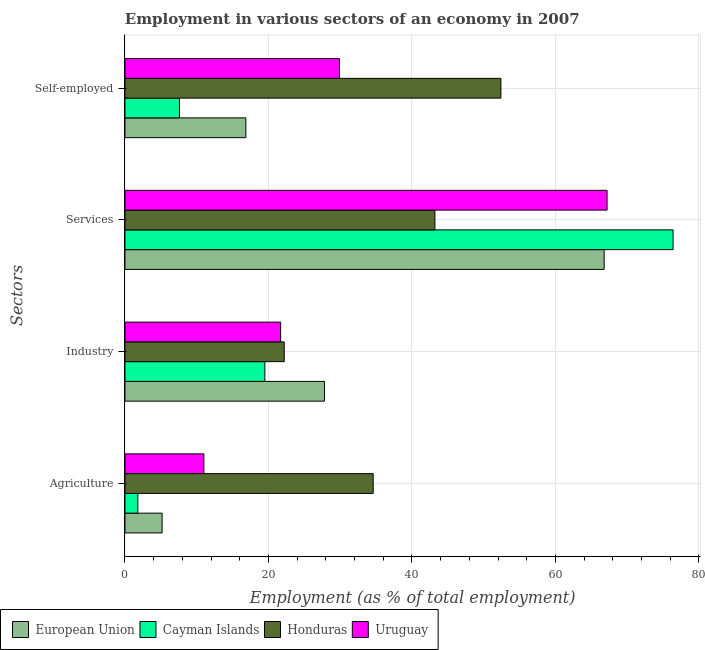How many different coloured bars are there?
Provide a succinct answer. 4. How many groups of bars are there?
Your response must be concise. 4. How many bars are there on the 4th tick from the top?
Make the answer very short. 4. How many bars are there on the 1st tick from the bottom?
Give a very brief answer. 4. What is the label of the 4th group of bars from the top?
Keep it short and to the point. Agriculture. What is the percentage of workers in services in European Union?
Provide a short and direct response. 66.79. Across all countries, what is the maximum percentage of workers in services?
Make the answer very short. 76.4. Across all countries, what is the minimum percentage of workers in services?
Your response must be concise. 43.2. In which country was the percentage of workers in agriculture maximum?
Your answer should be very brief. Honduras. In which country was the percentage of workers in services minimum?
Provide a succinct answer. Honduras. What is the total percentage of workers in agriculture in the graph?
Offer a very short reply. 52.58. What is the difference between the percentage of workers in agriculture in Cayman Islands and that in European Union?
Make the answer very short. -3.38. What is the difference between the percentage of workers in industry in European Union and the percentage of self employed workers in Cayman Islands?
Make the answer very short. 20.21. What is the average percentage of workers in services per country?
Your answer should be compact. 63.4. What is the difference between the percentage of workers in agriculture and percentage of self employed workers in Cayman Islands?
Provide a succinct answer. -5.8. What is the ratio of the percentage of workers in industry in European Union to that in Uruguay?
Provide a short and direct response. 1.28. Is the difference between the percentage of workers in services in European Union and Honduras greater than the difference between the percentage of workers in agriculture in European Union and Honduras?
Your answer should be very brief. Yes. What is the difference between the highest and the second highest percentage of workers in industry?
Your response must be concise. 5.61. What is the difference between the highest and the lowest percentage of workers in services?
Make the answer very short. 33.2. What does the 3rd bar from the top in Self-employed represents?
Offer a very short reply. Cayman Islands. What does the 4th bar from the bottom in Agriculture represents?
Offer a terse response. Uruguay. How many bars are there?
Make the answer very short. 16. How many countries are there in the graph?
Your answer should be compact. 4. Does the graph contain any zero values?
Provide a succinct answer. No. Where does the legend appear in the graph?
Offer a very short reply. Bottom left. How are the legend labels stacked?
Your response must be concise. Horizontal. What is the title of the graph?
Provide a short and direct response. Employment in various sectors of an economy in 2007. Does "Micronesia" appear as one of the legend labels in the graph?
Your answer should be compact. No. What is the label or title of the X-axis?
Your response must be concise. Employment (as % of total employment). What is the label or title of the Y-axis?
Your answer should be compact. Sectors. What is the Employment (as % of total employment) of European Union in Agriculture?
Offer a very short reply. 5.18. What is the Employment (as % of total employment) in Cayman Islands in Agriculture?
Offer a terse response. 1.8. What is the Employment (as % of total employment) in Honduras in Agriculture?
Offer a terse response. 34.6. What is the Employment (as % of total employment) of European Union in Industry?
Your response must be concise. 27.81. What is the Employment (as % of total employment) in Cayman Islands in Industry?
Your answer should be compact. 19.5. What is the Employment (as % of total employment) of Honduras in Industry?
Keep it short and to the point. 22.2. What is the Employment (as % of total employment) of Uruguay in Industry?
Your answer should be very brief. 21.7. What is the Employment (as % of total employment) in European Union in Services?
Keep it short and to the point. 66.79. What is the Employment (as % of total employment) of Cayman Islands in Services?
Your answer should be compact. 76.4. What is the Employment (as % of total employment) in Honduras in Services?
Your answer should be very brief. 43.2. What is the Employment (as % of total employment) of Uruguay in Services?
Your answer should be very brief. 67.2. What is the Employment (as % of total employment) in European Union in Self-employed?
Provide a succinct answer. 16.85. What is the Employment (as % of total employment) in Cayman Islands in Self-employed?
Your response must be concise. 7.6. What is the Employment (as % of total employment) in Honduras in Self-employed?
Offer a terse response. 52.4. What is the Employment (as % of total employment) in Uruguay in Self-employed?
Your response must be concise. 29.9. Across all Sectors, what is the maximum Employment (as % of total employment) in European Union?
Your answer should be compact. 66.79. Across all Sectors, what is the maximum Employment (as % of total employment) in Cayman Islands?
Your answer should be compact. 76.4. Across all Sectors, what is the maximum Employment (as % of total employment) in Honduras?
Your answer should be very brief. 52.4. Across all Sectors, what is the maximum Employment (as % of total employment) in Uruguay?
Your response must be concise. 67.2. Across all Sectors, what is the minimum Employment (as % of total employment) of European Union?
Ensure brevity in your answer.  5.18. Across all Sectors, what is the minimum Employment (as % of total employment) of Cayman Islands?
Ensure brevity in your answer.  1.8. Across all Sectors, what is the minimum Employment (as % of total employment) of Honduras?
Make the answer very short. 22.2. Across all Sectors, what is the minimum Employment (as % of total employment) of Uruguay?
Offer a terse response. 11. What is the total Employment (as % of total employment) of European Union in the graph?
Offer a very short reply. 116.63. What is the total Employment (as % of total employment) of Cayman Islands in the graph?
Provide a succinct answer. 105.3. What is the total Employment (as % of total employment) in Honduras in the graph?
Provide a short and direct response. 152.4. What is the total Employment (as % of total employment) in Uruguay in the graph?
Provide a short and direct response. 129.8. What is the difference between the Employment (as % of total employment) in European Union in Agriculture and that in Industry?
Give a very brief answer. -22.63. What is the difference between the Employment (as % of total employment) in Cayman Islands in Agriculture and that in Industry?
Your answer should be compact. -17.7. What is the difference between the Employment (as % of total employment) of Honduras in Agriculture and that in Industry?
Provide a succinct answer. 12.4. What is the difference between the Employment (as % of total employment) in Uruguay in Agriculture and that in Industry?
Your answer should be compact. -10.7. What is the difference between the Employment (as % of total employment) of European Union in Agriculture and that in Services?
Give a very brief answer. -61.61. What is the difference between the Employment (as % of total employment) of Cayman Islands in Agriculture and that in Services?
Keep it short and to the point. -74.6. What is the difference between the Employment (as % of total employment) of Honduras in Agriculture and that in Services?
Offer a terse response. -8.6. What is the difference between the Employment (as % of total employment) in Uruguay in Agriculture and that in Services?
Provide a succinct answer. -56.2. What is the difference between the Employment (as % of total employment) of European Union in Agriculture and that in Self-employed?
Offer a very short reply. -11.67. What is the difference between the Employment (as % of total employment) of Honduras in Agriculture and that in Self-employed?
Ensure brevity in your answer.  -17.8. What is the difference between the Employment (as % of total employment) of Uruguay in Agriculture and that in Self-employed?
Your answer should be compact. -18.9. What is the difference between the Employment (as % of total employment) of European Union in Industry and that in Services?
Your answer should be compact. -38.98. What is the difference between the Employment (as % of total employment) in Cayman Islands in Industry and that in Services?
Your answer should be compact. -56.9. What is the difference between the Employment (as % of total employment) of Uruguay in Industry and that in Services?
Offer a terse response. -45.5. What is the difference between the Employment (as % of total employment) in European Union in Industry and that in Self-employed?
Provide a short and direct response. 10.96. What is the difference between the Employment (as % of total employment) in Cayman Islands in Industry and that in Self-employed?
Your response must be concise. 11.9. What is the difference between the Employment (as % of total employment) in Honduras in Industry and that in Self-employed?
Provide a succinct answer. -30.2. What is the difference between the Employment (as % of total employment) of European Union in Services and that in Self-employed?
Keep it short and to the point. 49.94. What is the difference between the Employment (as % of total employment) of Cayman Islands in Services and that in Self-employed?
Your answer should be very brief. 68.8. What is the difference between the Employment (as % of total employment) in Honduras in Services and that in Self-employed?
Keep it short and to the point. -9.2. What is the difference between the Employment (as % of total employment) in Uruguay in Services and that in Self-employed?
Make the answer very short. 37.3. What is the difference between the Employment (as % of total employment) in European Union in Agriculture and the Employment (as % of total employment) in Cayman Islands in Industry?
Your answer should be compact. -14.32. What is the difference between the Employment (as % of total employment) of European Union in Agriculture and the Employment (as % of total employment) of Honduras in Industry?
Make the answer very short. -17.02. What is the difference between the Employment (as % of total employment) of European Union in Agriculture and the Employment (as % of total employment) of Uruguay in Industry?
Provide a succinct answer. -16.52. What is the difference between the Employment (as % of total employment) of Cayman Islands in Agriculture and the Employment (as % of total employment) of Honduras in Industry?
Offer a terse response. -20.4. What is the difference between the Employment (as % of total employment) in Cayman Islands in Agriculture and the Employment (as % of total employment) in Uruguay in Industry?
Your answer should be very brief. -19.9. What is the difference between the Employment (as % of total employment) of Honduras in Agriculture and the Employment (as % of total employment) of Uruguay in Industry?
Provide a short and direct response. 12.9. What is the difference between the Employment (as % of total employment) in European Union in Agriculture and the Employment (as % of total employment) in Cayman Islands in Services?
Your response must be concise. -71.22. What is the difference between the Employment (as % of total employment) of European Union in Agriculture and the Employment (as % of total employment) of Honduras in Services?
Your answer should be compact. -38.02. What is the difference between the Employment (as % of total employment) of European Union in Agriculture and the Employment (as % of total employment) of Uruguay in Services?
Your answer should be very brief. -62.02. What is the difference between the Employment (as % of total employment) of Cayman Islands in Agriculture and the Employment (as % of total employment) of Honduras in Services?
Your response must be concise. -41.4. What is the difference between the Employment (as % of total employment) of Cayman Islands in Agriculture and the Employment (as % of total employment) of Uruguay in Services?
Give a very brief answer. -65.4. What is the difference between the Employment (as % of total employment) in Honduras in Agriculture and the Employment (as % of total employment) in Uruguay in Services?
Ensure brevity in your answer.  -32.6. What is the difference between the Employment (as % of total employment) in European Union in Agriculture and the Employment (as % of total employment) in Cayman Islands in Self-employed?
Give a very brief answer. -2.42. What is the difference between the Employment (as % of total employment) of European Union in Agriculture and the Employment (as % of total employment) of Honduras in Self-employed?
Your response must be concise. -47.22. What is the difference between the Employment (as % of total employment) in European Union in Agriculture and the Employment (as % of total employment) in Uruguay in Self-employed?
Provide a short and direct response. -24.72. What is the difference between the Employment (as % of total employment) in Cayman Islands in Agriculture and the Employment (as % of total employment) in Honduras in Self-employed?
Make the answer very short. -50.6. What is the difference between the Employment (as % of total employment) of Cayman Islands in Agriculture and the Employment (as % of total employment) of Uruguay in Self-employed?
Your answer should be compact. -28.1. What is the difference between the Employment (as % of total employment) of Honduras in Agriculture and the Employment (as % of total employment) of Uruguay in Self-employed?
Provide a succinct answer. 4.7. What is the difference between the Employment (as % of total employment) in European Union in Industry and the Employment (as % of total employment) in Cayman Islands in Services?
Make the answer very short. -48.59. What is the difference between the Employment (as % of total employment) of European Union in Industry and the Employment (as % of total employment) of Honduras in Services?
Your response must be concise. -15.39. What is the difference between the Employment (as % of total employment) in European Union in Industry and the Employment (as % of total employment) in Uruguay in Services?
Your response must be concise. -39.39. What is the difference between the Employment (as % of total employment) in Cayman Islands in Industry and the Employment (as % of total employment) in Honduras in Services?
Your response must be concise. -23.7. What is the difference between the Employment (as % of total employment) in Cayman Islands in Industry and the Employment (as % of total employment) in Uruguay in Services?
Your answer should be compact. -47.7. What is the difference between the Employment (as % of total employment) of Honduras in Industry and the Employment (as % of total employment) of Uruguay in Services?
Make the answer very short. -45. What is the difference between the Employment (as % of total employment) of European Union in Industry and the Employment (as % of total employment) of Cayman Islands in Self-employed?
Provide a short and direct response. 20.21. What is the difference between the Employment (as % of total employment) in European Union in Industry and the Employment (as % of total employment) in Honduras in Self-employed?
Provide a succinct answer. -24.59. What is the difference between the Employment (as % of total employment) in European Union in Industry and the Employment (as % of total employment) in Uruguay in Self-employed?
Make the answer very short. -2.09. What is the difference between the Employment (as % of total employment) in Cayman Islands in Industry and the Employment (as % of total employment) in Honduras in Self-employed?
Keep it short and to the point. -32.9. What is the difference between the Employment (as % of total employment) in Honduras in Industry and the Employment (as % of total employment) in Uruguay in Self-employed?
Make the answer very short. -7.7. What is the difference between the Employment (as % of total employment) of European Union in Services and the Employment (as % of total employment) of Cayman Islands in Self-employed?
Provide a succinct answer. 59.19. What is the difference between the Employment (as % of total employment) of European Union in Services and the Employment (as % of total employment) of Honduras in Self-employed?
Your answer should be very brief. 14.39. What is the difference between the Employment (as % of total employment) in European Union in Services and the Employment (as % of total employment) in Uruguay in Self-employed?
Make the answer very short. 36.89. What is the difference between the Employment (as % of total employment) of Cayman Islands in Services and the Employment (as % of total employment) of Uruguay in Self-employed?
Provide a short and direct response. 46.5. What is the average Employment (as % of total employment) in European Union per Sectors?
Keep it short and to the point. 29.16. What is the average Employment (as % of total employment) in Cayman Islands per Sectors?
Give a very brief answer. 26.32. What is the average Employment (as % of total employment) of Honduras per Sectors?
Your answer should be very brief. 38.1. What is the average Employment (as % of total employment) in Uruguay per Sectors?
Keep it short and to the point. 32.45. What is the difference between the Employment (as % of total employment) in European Union and Employment (as % of total employment) in Cayman Islands in Agriculture?
Your answer should be very brief. 3.38. What is the difference between the Employment (as % of total employment) of European Union and Employment (as % of total employment) of Honduras in Agriculture?
Provide a succinct answer. -29.42. What is the difference between the Employment (as % of total employment) in European Union and Employment (as % of total employment) in Uruguay in Agriculture?
Your answer should be very brief. -5.82. What is the difference between the Employment (as % of total employment) of Cayman Islands and Employment (as % of total employment) of Honduras in Agriculture?
Your response must be concise. -32.8. What is the difference between the Employment (as % of total employment) of Cayman Islands and Employment (as % of total employment) of Uruguay in Agriculture?
Keep it short and to the point. -9.2. What is the difference between the Employment (as % of total employment) of Honduras and Employment (as % of total employment) of Uruguay in Agriculture?
Your answer should be compact. 23.6. What is the difference between the Employment (as % of total employment) of European Union and Employment (as % of total employment) of Cayman Islands in Industry?
Provide a succinct answer. 8.31. What is the difference between the Employment (as % of total employment) of European Union and Employment (as % of total employment) of Honduras in Industry?
Provide a succinct answer. 5.61. What is the difference between the Employment (as % of total employment) of European Union and Employment (as % of total employment) of Uruguay in Industry?
Give a very brief answer. 6.11. What is the difference between the Employment (as % of total employment) of Cayman Islands and Employment (as % of total employment) of Honduras in Industry?
Offer a terse response. -2.7. What is the difference between the Employment (as % of total employment) of Cayman Islands and Employment (as % of total employment) of Uruguay in Industry?
Offer a very short reply. -2.2. What is the difference between the Employment (as % of total employment) in European Union and Employment (as % of total employment) in Cayman Islands in Services?
Make the answer very short. -9.61. What is the difference between the Employment (as % of total employment) of European Union and Employment (as % of total employment) of Honduras in Services?
Your response must be concise. 23.59. What is the difference between the Employment (as % of total employment) in European Union and Employment (as % of total employment) in Uruguay in Services?
Make the answer very short. -0.41. What is the difference between the Employment (as % of total employment) of Cayman Islands and Employment (as % of total employment) of Honduras in Services?
Ensure brevity in your answer.  33.2. What is the difference between the Employment (as % of total employment) of European Union and Employment (as % of total employment) of Cayman Islands in Self-employed?
Provide a short and direct response. 9.25. What is the difference between the Employment (as % of total employment) in European Union and Employment (as % of total employment) in Honduras in Self-employed?
Provide a succinct answer. -35.55. What is the difference between the Employment (as % of total employment) of European Union and Employment (as % of total employment) of Uruguay in Self-employed?
Your answer should be very brief. -13.05. What is the difference between the Employment (as % of total employment) of Cayman Islands and Employment (as % of total employment) of Honduras in Self-employed?
Your answer should be very brief. -44.8. What is the difference between the Employment (as % of total employment) in Cayman Islands and Employment (as % of total employment) in Uruguay in Self-employed?
Your response must be concise. -22.3. What is the difference between the Employment (as % of total employment) in Honduras and Employment (as % of total employment) in Uruguay in Self-employed?
Make the answer very short. 22.5. What is the ratio of the Employment (as % of total employment) in European Union in Agriculture to that in Industry?
Make the answer very short. 0.19. What is the ratio of the Employment (as % of total employment) in Cayman Islands in Agriculture to that in Industry?
Give a very brief answer. 0.09. What is the ratio of the Employment (as % of total employment) of Honduras in Agriculture to that in Industry?
Keep it short and to the point. 1.56. What is the ratio of the Employment (as % of total employment) in Uruguay in Agriculture to that in Industry?
Your answer should be very brief. 0.51. What is the ratio of the Employment (as % of total employment) in European Union in Agriculture to that in Services?
Provide a short and direct response. 0.08. What is the ratio of the Employment (as % of total employment) in Cayman Islands in Agriculture to that in Services?
Offer a very short reply. 0.02. What is the ratio of the Employment (as % of total employment) in Honduras in Agriculture to that in Services?
Your response must be concise. 0.8. What is the ratio of the Employment (as % of total employment) in Uruguay in Agriculture to that in Services?
Keep it short and to the point. 0.16. What is the ratio of the Employment (as % of total employment) in European Union in Agriculture to that in Self-employed?
Give a very brief answer. 0.31. What is the ratio of the Employment (as % of total employment) of Cayman Islands in Agriculture to that in Self-employed?
Offer a terse response. 0.24. What is the ratio of the Employment (as % of total employment) in Honduras in Agriculture to that in Self-employed?
Make the answer very short. 0.66. What is the ratio of the Employment (as % of total employment) in Uruguay in Agriculture to that in Self-employed?
Offer a terse response. 0.37. What is the ratio of the Employment (as % of total employment) in European Union in Industry to that in Services?
Provide a short and direct response. 0.42. What is the ratio of the Employment (as % of total employment) in Cayman Islands in Industry to that in Services?
Offer a terse response. 0.26. What is the ratio of the Employment (as % of total employment) in Honduras in Industry to that in Services?
Offer a terse response. 0.51. What is the ratio of the Employment (as % of total employment) of Uruguay in Industry to that in Services?
Provide a short and direct response. 0.32. What is the ratio of the Employment (as % of total employment) of European Union in Industry to that in Self-employed?
Offer a very short reply. 1.65. What is the ratio of the Employment (as % of total employment) in Cayman Islands in Industry to that in Self-employed?
Give a very brief answer. 2.57. What is the ratio of the Employment (as % of total employment) of Honduras in Industry to that in Self-employed?
Offer a terse response. 0.42. What is the ratio of the Employment (as % of total employment) of Uruguay in Industry to that in Self-employed?
Provide a short and direct response. 0.73. What is the ratio of the Employment (as % of total employment) in European Union in Services to that in Self-employed?
Your answer should be very brief. 3.96. What is the ratio of the Employment (as % of total employment) of Cayman Islands in Services to that in Self-employed?
Give a very brief answer. 10.05. What is the ratio of the Employment (as % of total employment) of Honduras in Services to that in Self-employed?
Keep it short and to the point. 0.82. What is the ratio of the Employment (as % of total employment) of Uruguay in Services to that in Self-employed?
Make the answer very short. 2.25. What is the difference between the highest and the second highest Employment (as % of total employment) of European Union?
Your answer should be compact. 38.98. What is the difference between the highest and the second highest Employment (as % of total employment) in Cayman Islands?
Offer a very short reply. 56.9. What is the difference between the highest and the second highest Employment (as % of total employment) of Honduras?
Give a very brief answer. 9.2. What is the difference between the highest and the second highest Employment (as % of total employment) of Uruguay?
Offer a terse response. 37.3. What is the difference between the highest and the lowest Employment (as % of total employment) of European Union?
Provide a succinct answer. 61.61. What is the difference between the highest and the lowest Employment (as % of total employment) in Cayman Islands?
Offer a terse response. 74.6. What is the difference between the highest and the lowest Employment (as % of total employment) in Honduras?
Your answer should be compact. 30.2. What is the difference between the highest and the lowest Employment (as % of total employment) in Uruguay?
Ensure brevity in your answer.  56.2. 